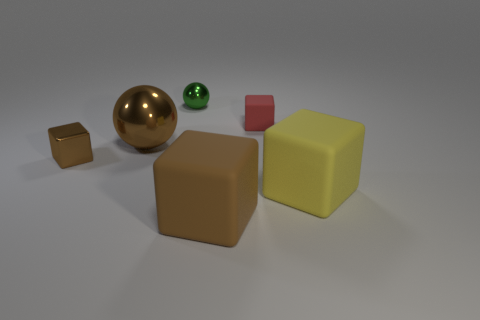Subtract all matte cubes. How many cubes are left? 1 Subtract all brown cylinders. How many brown blocks are left? 2 Add 1 shiny things. How many objects exist? 7 Subtract all yellow blocks. How many blocks are left? 3 Subtract all spheres. How many objects are left? 4 Subtract all cyan cubes. Subtract all brown cylinders. How many cubes are left? 4 Subtract all rubber blocks. Subtract all big cyan rubber objects. How many objects are left? 3 Add 1 small red matte cubes. How many small red matte cubes are left? 2 Add 2 large yellow matte things. How many large yellow matte things exist? 3 Subtract 0 purple balls. How many objects are left? 6 